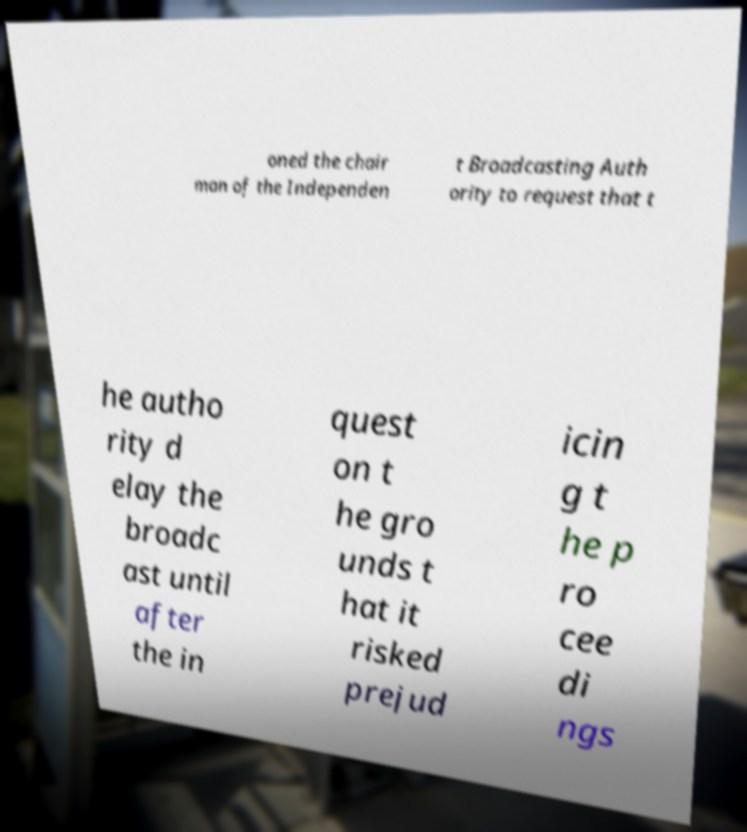Could you assist in decoding the text presented in this image and type it out clearly? oned the chair man of the Independen t Broadcasting Auth ority to request that t he autho rity d elay the broadc ast until after the in quest on t he gro unds t hat it risked prejud icin g t he p ro cee di ngs 